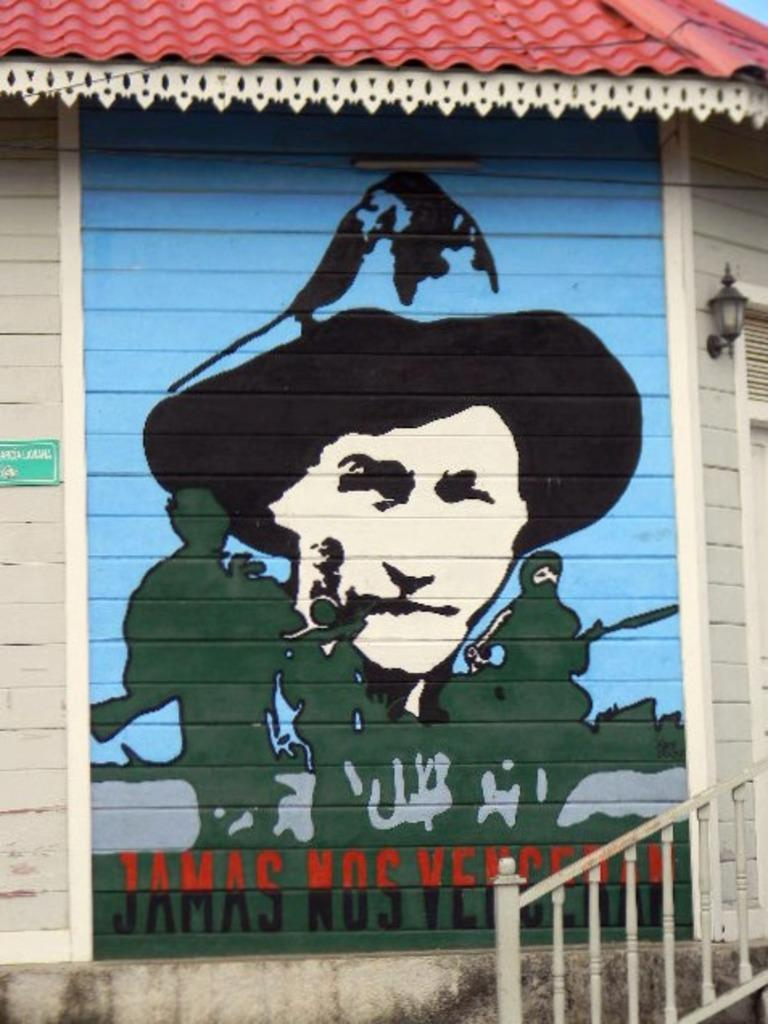What is present on the wall in the image? There is a painting on the wall in the image. Where are the stairs located in the image? The stairs are on the right side of the image. What is the color of the railing associated with the stairs? The railing is white in color. What type of jewel can be seen on the painting in the image? There is no jewel present on the painting in the image. How does the railing provide a grip for people using the stairs in the image? The railing is not shown to be providing a grip for people using the stairs in the image, as it is not mentioned in the provided facts. 